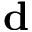Convert formula to latex. <formula><loc_0><loc_0><loc_500><loc_500>d</formula> 